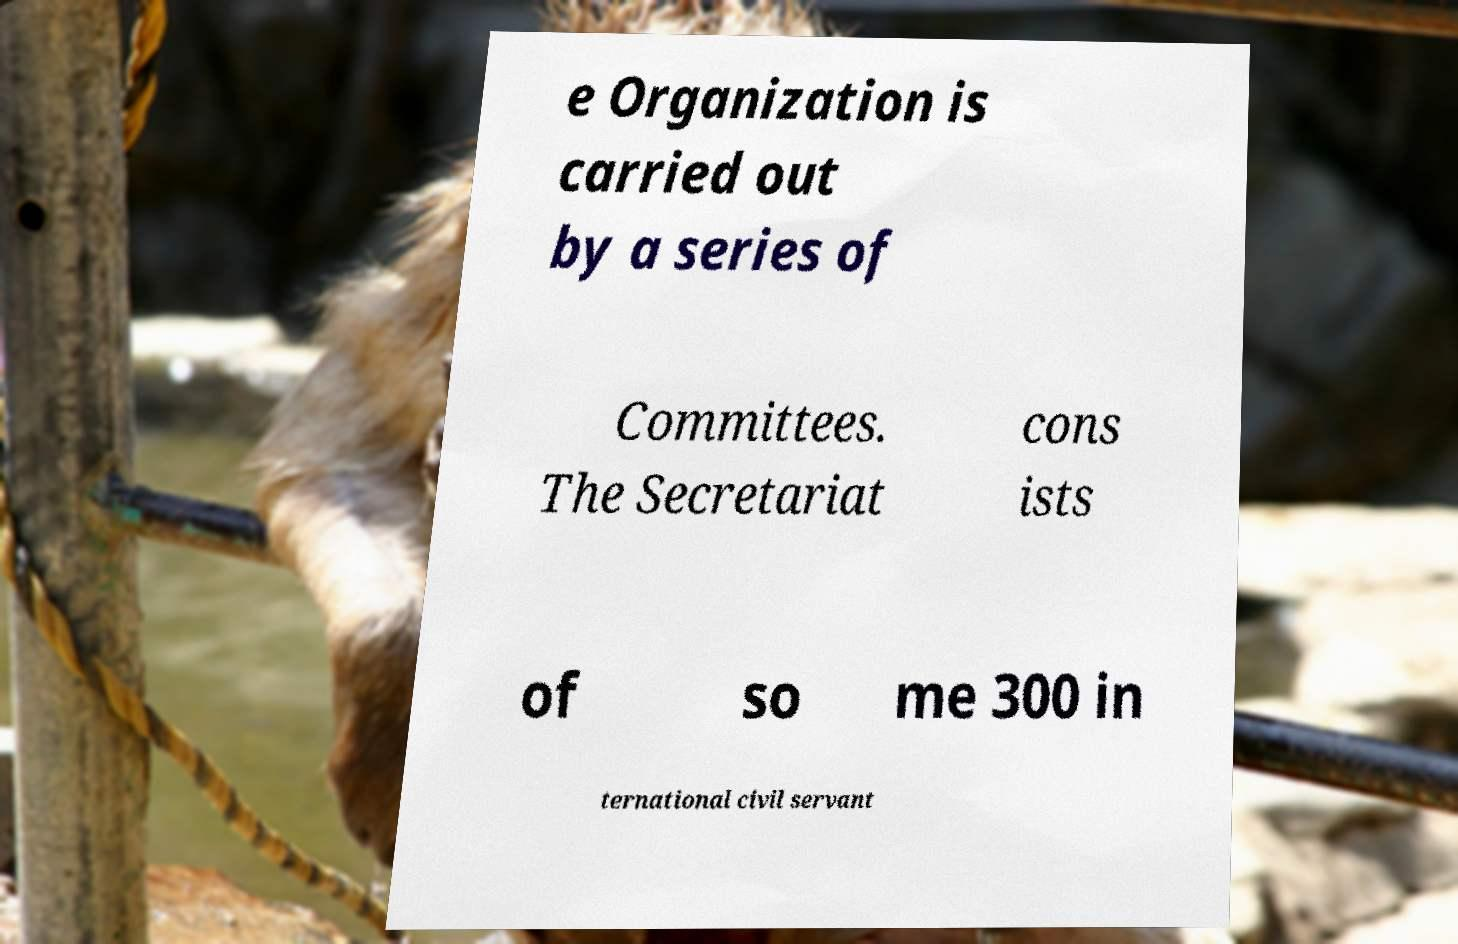Please read and relay the text visible in this image. What does it say? e Organization is carried out by a series of Committees. The Secretariat cons ists of so me 300 in ternational civil servant 